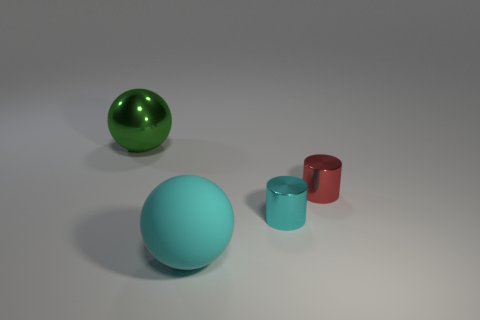Are these objects illuminated by natural or artificial light? The objects appear to be illuminated by artificial light, likely from a source outside of the frame, as indicated by the uniform shadows and consistent lighting across the scene. 